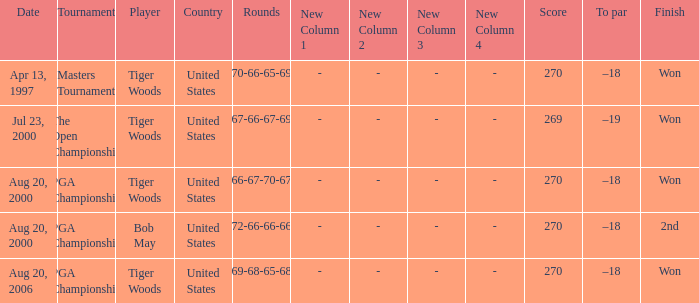What country hosts the tournament the open championship? United States. 